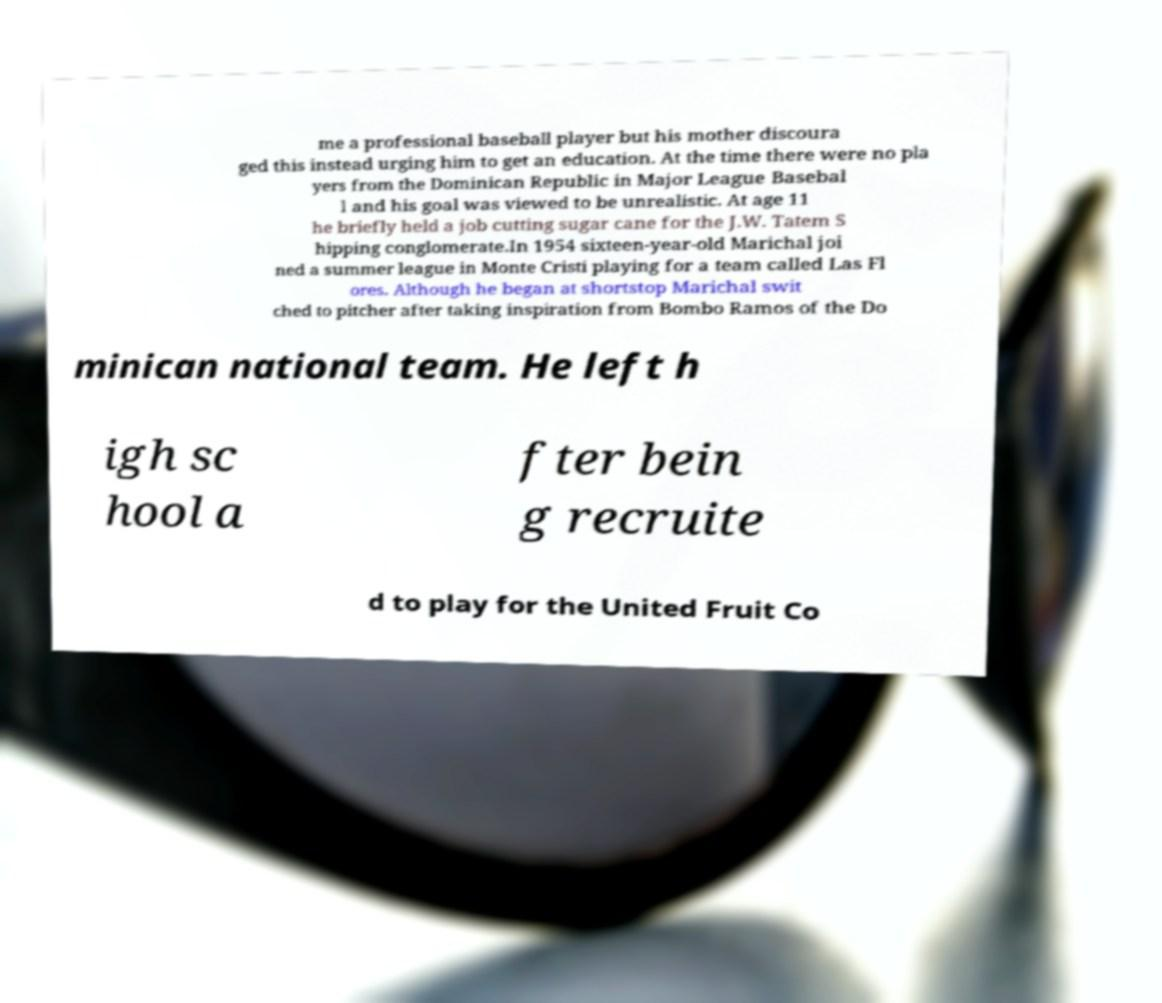Could you extract and type out the text from this image? me a professional baseball player but his mother discoura ged this instead urging him to get an education. At the time there were no pla yers from the Dominican Republic in Major League Basebal l and his goal was viewed to be unrealistic. At age 11 he briefly held a job cutting sugar cane for the J.W. Tatem S hipping conglomerate.In 1954 sixteen-year-old Marichal joi ned a summer league in Monte Cristi playing for a team called Las Fl ores. Although he began at shortstop Marichal swit ched to pitcher after taking inspiration from Bombo Ramos of the Do minican national team. He left h igh sc hool a fter bein g recruite d to play for the United Fruit Co 